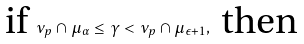<formula> <loc_0><loc_0><loc_500><loc_500>\text {if } \nu _ { p } \cap \mu _ { \alpha } \leq \gamma < \nu _ { p } \cap \mu _ { \epsilon + 1 } , \text { then }</formula> 